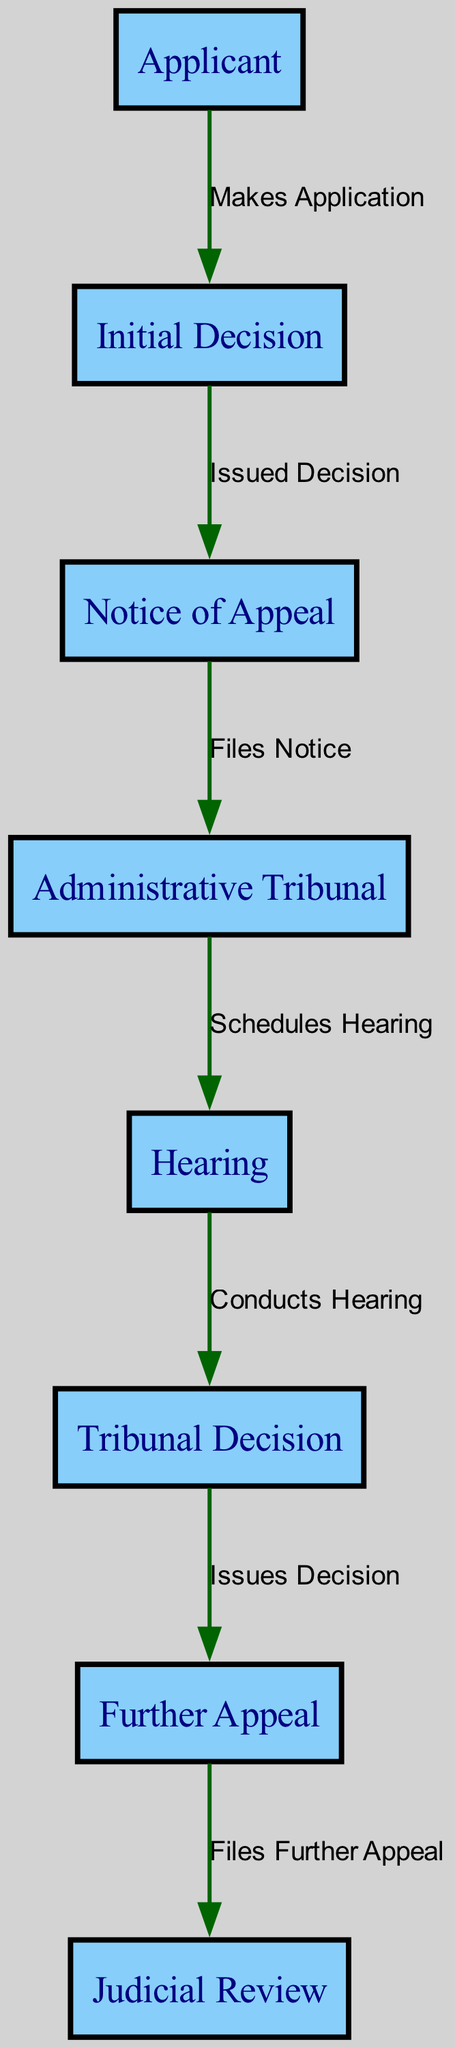What is the first step in the appeals process? The first step in the appeals process is initiated by the applicant who makes an application. This is represented by the arrow from the "Applicant" node to the "Initial Decision" node with the label "Makes Application."
Answer: Makes Application How many nodes are present in the diagram? The diagram contains a total of 8 nodes: Applicant, Initial Decision, Notice of Appeal, Administrative Tribunal, Hearing, Tribunal Decision, Further Appeal, and Judicial Review. This can be confirmed by counting the distinct nodes listed in the data provided.
Answer: 8 What is the relationship between the "Initial Decision" and "Notice of Appeal"? The relationship between "Initial Decision" and "Notice of Appeal" is depicted by the edge from the "Initial Decision" node to the "Notice of Appeal" node, labeled "Issued Decision." This indicates that the Notice of Appeal is generated after the Initial Decision is made.
Answer: Issued Decision Which node follows the "Hearing" in the process? After the "Hearing," the next node is "Tribunal Decision." This is represented by the arrow leading from the "Hearing" node to the "Tribunal Decision" node with the label "Conducts Hearing," indicating the sequence.
Answer: Tribunal Decision What is the final step in the appeals process according to the diagram? The final step in the appeals process is "Judicial Review," which follows the "Further Appeal." This is represented by the edge from the "Further Appeal" node to the "Judicial Review" node, labeled "Files Further Appeal."
Answer: Judicial Review What action does the applicant take after the "Initial Decision" is made? After the "Initial Decision" is made, the applicant files a "Notice of Appeal." This is seen in the transition from the "Initial Decision" node to the "Notice of Appeal" node labeled "Issued Decision," indicating the next action the applicant must take.
Answer: Files Notice How many edges are in the diagram? There are 7 edges in the diagram, each representing a specific action or relationship between the nodes. This can be confirmed by counting the connections outlined in the data.
Answer: 7 What happens after the "Tribunal Decision" is issued? After the "Tribunal Decision" is issued, the next action is to file a "Further Appeal." This is shown as the transition from "Tribunal Decision" to "Further Appeal" with the label "Issues Decision."
Answer: Files Further Appeal 